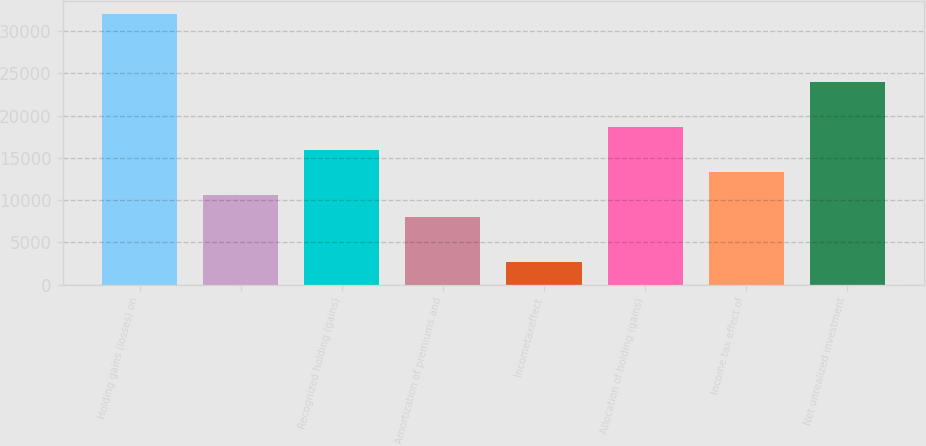Convert chart. <chart><loc_0><loc_0><loc_500><loc_500><bar_chart><fcel>Holding gains (losses) on<fcel>Unnamed: 1<fcel>Recognized holding (gains)<fcel>Amortization of premiums and<fcel>Incometaxeffect<fcel>Allocation of holding (gains)<fcel>Income tax effect of<fcel>Net unrealized investment<nl><fcel>31978<fcel>10666<fcel>15994<fcel>8002<fcel>2674<fcel>18658<fcel>13330<fcel>23986<nl></chart> 